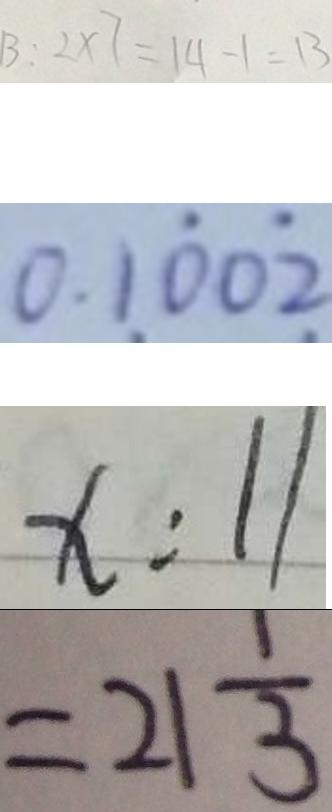<formula> <loc_0><loc_0><loc_500><loc_500>B : 2 \times 7 = 1 4 - 1 = 1 3 
 0 . 1 \dot { 0 } 0 \dot { 2 } 
 x : 1 1 
 = 2 1 \frac { 1 } { 3 }</formula> 